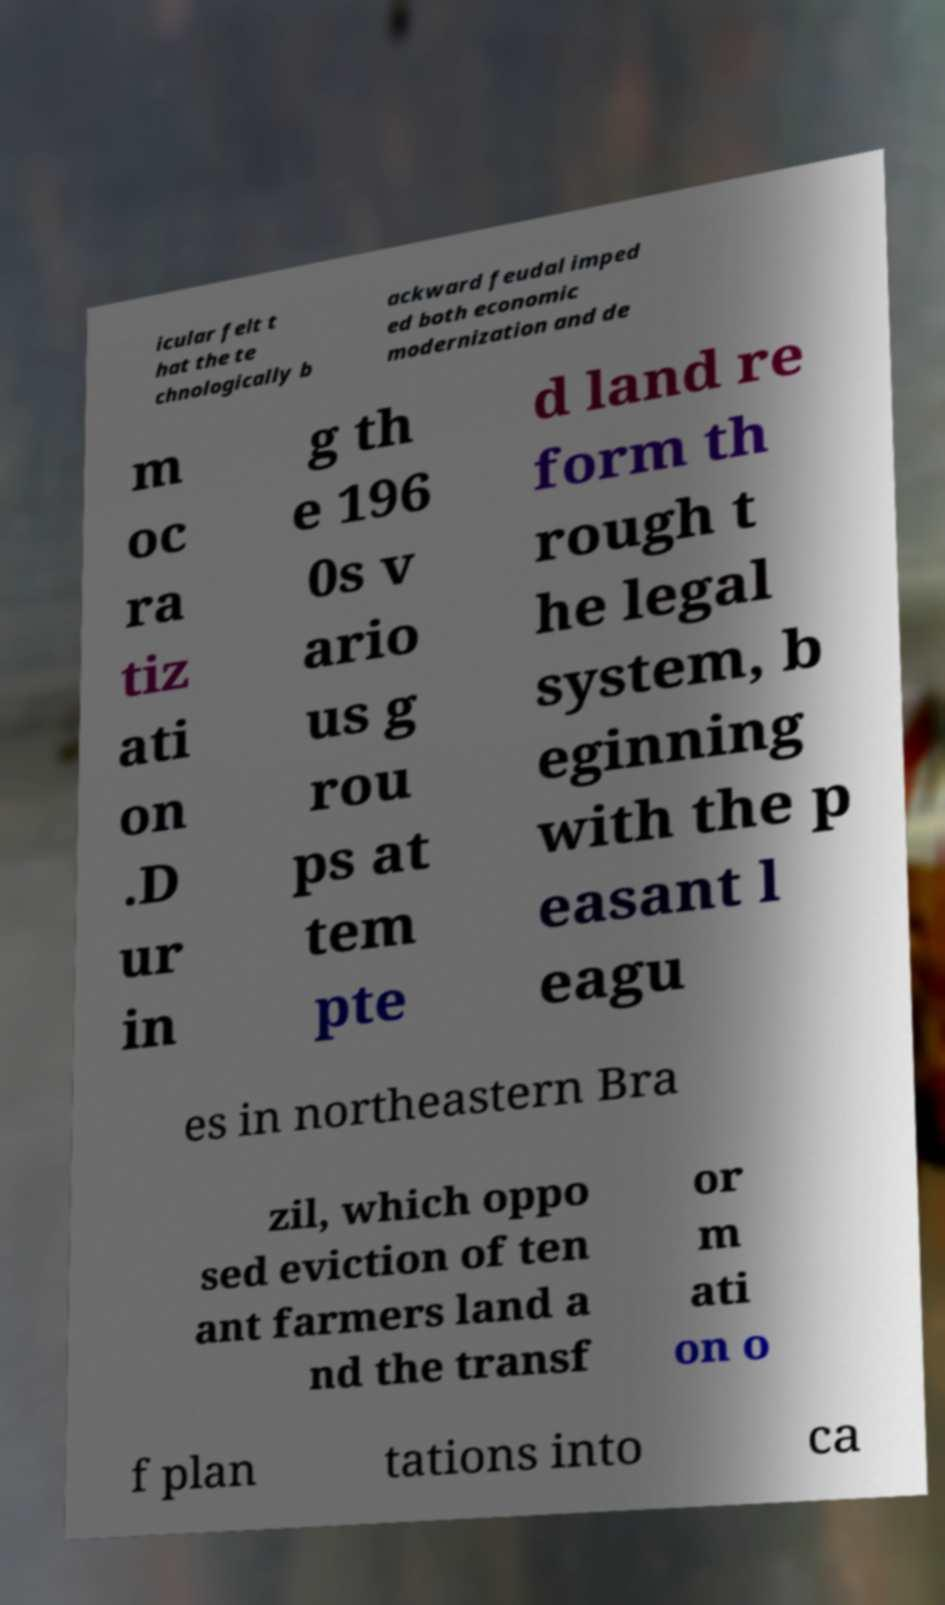For documentation purposes, I need the text within this image transcribed. Could you provide that? icular felt t hat the te chnologically b ackward feudal imped ed both economic modernization and de m oc ra tiz ati on .D ur in g th e 196 0s v ario us g rou ps at tem pte d land re form th rough t he legal system, b eginning with the p easant l eagu es in northeastern Bra zil, which oppo sed eviction of ten ant farmers land a nd the transf or m ati on o f plan tations into ca 